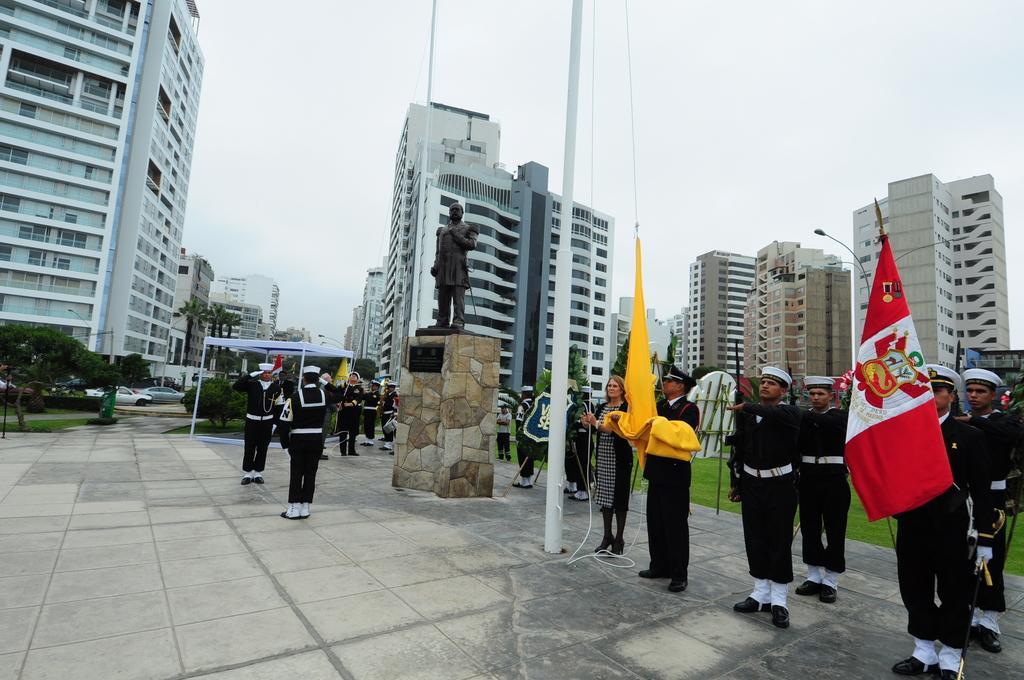Please provide a concise description of this image. In the picture we can see a path with tiles on it, we can see some people are standing holding two flags and near to them, we can see a pole and a man sculpture and beside it also we can see some people are standing at the uniforms and behind them, we can see a tent and behind it we can see some plants and in the background we can see some tower buildings with many floors and behind it we can see a sky. 